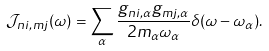<formula> <loc_0><loc_0><loc_500><loc_500>\mathcal { J } _ { n i , m j } ( \omega ) = \sum _ { \alpha } \frac { g _ { n i , \alpha } g _ { m j , \alpha } } { 2 m _ { \alpha } \omega _ { \alpha } } \delta ( \omega - \omega _ { \alpha } ) .</formula> 